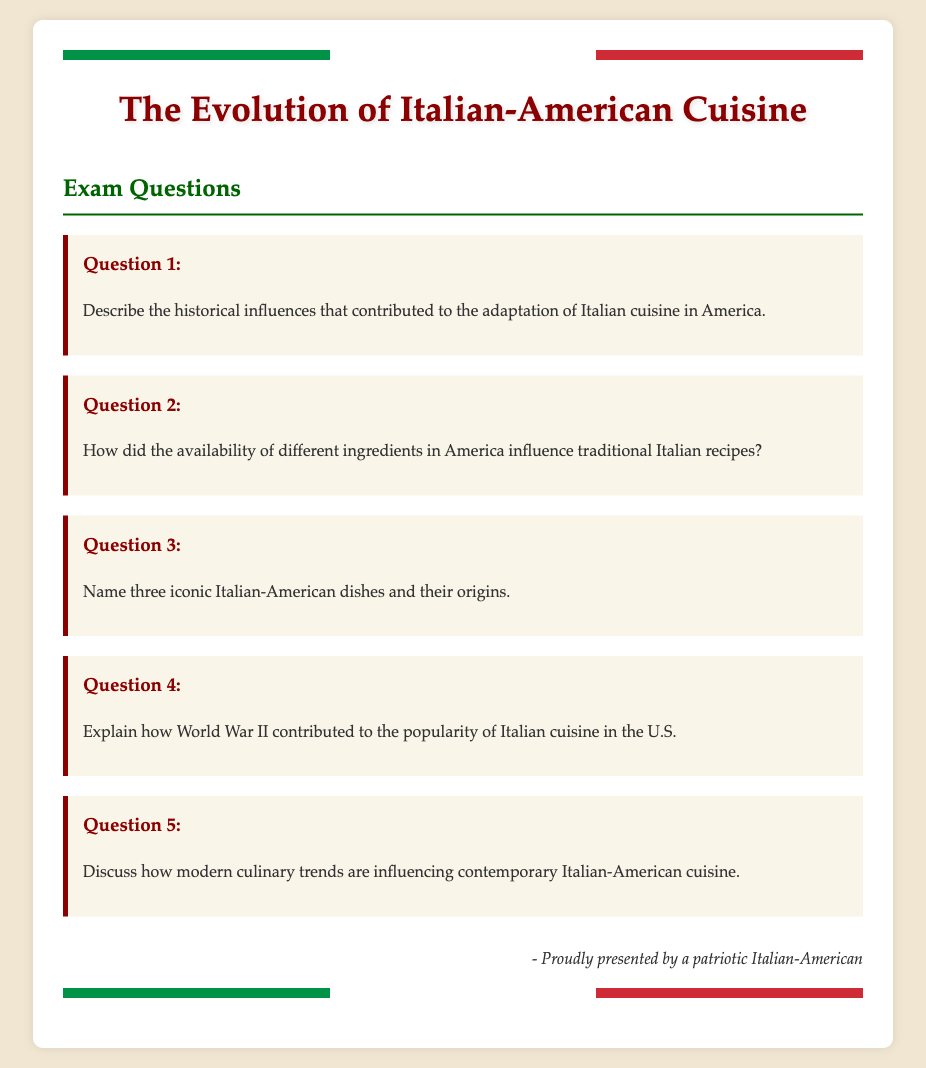What is the title of the document? The title of the document is displayed prominently at the top as "The Evolution of Italian-American Cuisine."
Answer: The Evolution of Italian-American Cuisine How many exam questions are presented in the document? The document contains a total of five exam questions.
Answer: Five What color is used for the header text? The header text uses a dark red color identified in the style section.
Answer: Dark red Which historical event is mentioned as influencing the popularity of Italian cuisine in the U.S.? The document specifies World War II as a historical event that contributed to the popularity.
Answer: World War II What is the theme of the exam? The exam theme focuses on the integration and evolution of Italian-American cuisine in mainstream American food culture.
Answer: Italian-American cuisine What type of cuisine is the focus of the exam? The exam specifically focuses on Italian-American cuisine and its historical context.
Answer: Italian-American cuisine What is one culinary trend mentioned as influencing contemporary Italian-American cuisine? The document discusses modern culinary trends but does not specify a particular trend in the provided questions.
Answer: N/A Who is the presented author of the exam document? The author of the document is identified as a patriotic Italian-American in the signature section.
Answer: A patriotic Italian-American 